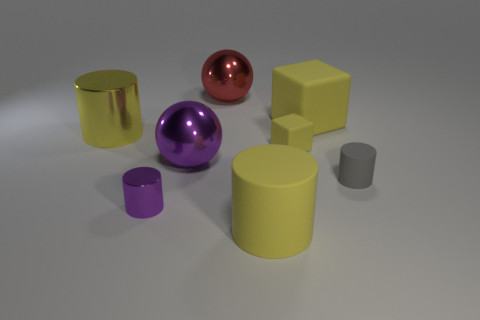Subtract all big matte cylinders. How many cylinders are left? 3 Add 1 large yellow cubes. How many objects exist? 9 Subtract all purple cylinders. How many cylinders are left? 3 Subtract all spheres. How many objects are left? 6 Subtract all blue spheres. How many yellow cylinders are left? 2 Subtract 3 cylinders. How many cylinders are left? 1 Subtract all brown cylinders. Subtract all gray blocks. How many cylinders are left? 4 Subtract all large yellow matte objects. Subtract all large blocks. How many objects are left? 5 Add 4 tiny gray objects. How many tiny gray objects are left? 5 Add 7 gray objects. How many gray objects exist? 8 